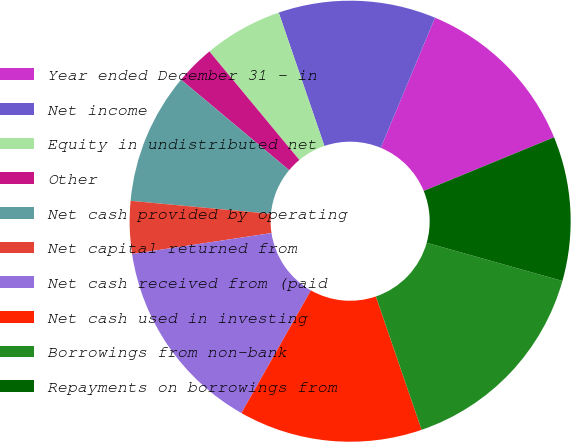Convert chart to OTSL. <chart><loc_0><loc_0><loc_500><loc_500><pie_chart><fcel>Year ended December 31 - in<fcel>Net income<fcel>Equity in undistributed net<fcel>Other<fcel>Net cash provided by operating<fcel>Net capital returned from<fcel>Net cash received from (paid<fcel>Net cash used in investing<fcel>Borrowings from non-bank<fcel>Repayments on borrowings from<nl><fcel>12.5%<fcel>11.54%<fcel>5.77%<fcel>2.89%<fcel>9.62%<fcel>3.85%<fcel>14.42%<fcel>13.46%<fcel>15.38%<fcel>10.58%<nl></chart> 